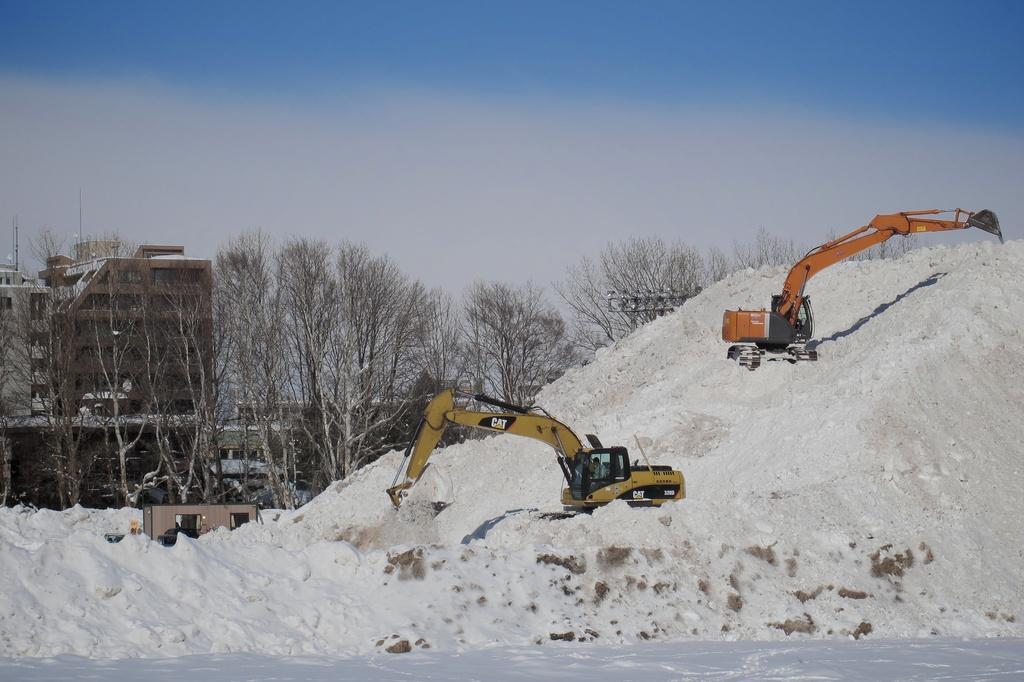How would you summarize this image in a sentence or two? In this image there is snow at the bottom. There is snow, people and proclaimers in the foreground. There are trees and buildings in the background. There is sky at the top. 